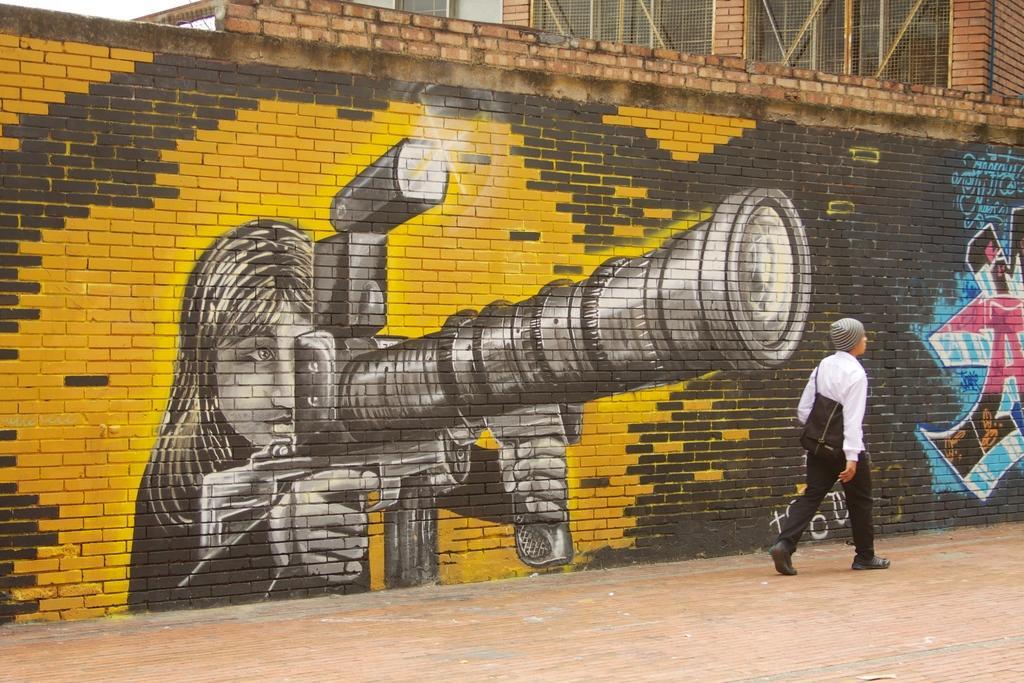In one or two sentences, can you explain what this image depicts? In this image we can see a person wearing white dress, cap, backpack and shoes is walking on the road. In the background, we can see a wall on which we can see the art of a person holding a weapon. Here we can see the brick building with mesh windows. 